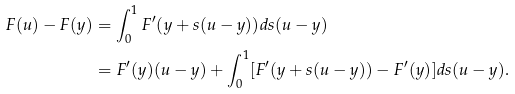Convert formula to latex. <formula><loc_0><loc_0><loc_500><loc_500>F ( u ) - F ( y ) & = \int _ { 0 } ^ { 1 } F ^ { \prime } ( y + s ( u - y ) ) d s ( u - y ) \\ & = F ^ { \prime } ( y ) ( u - y ) + \int _ { 0 } ^ { 1 } [ F ^ { \prime } ( y + s ( u - y ) ) - F ^ { \prime } ( y ) ] d s ( u - y ) .</formula> 